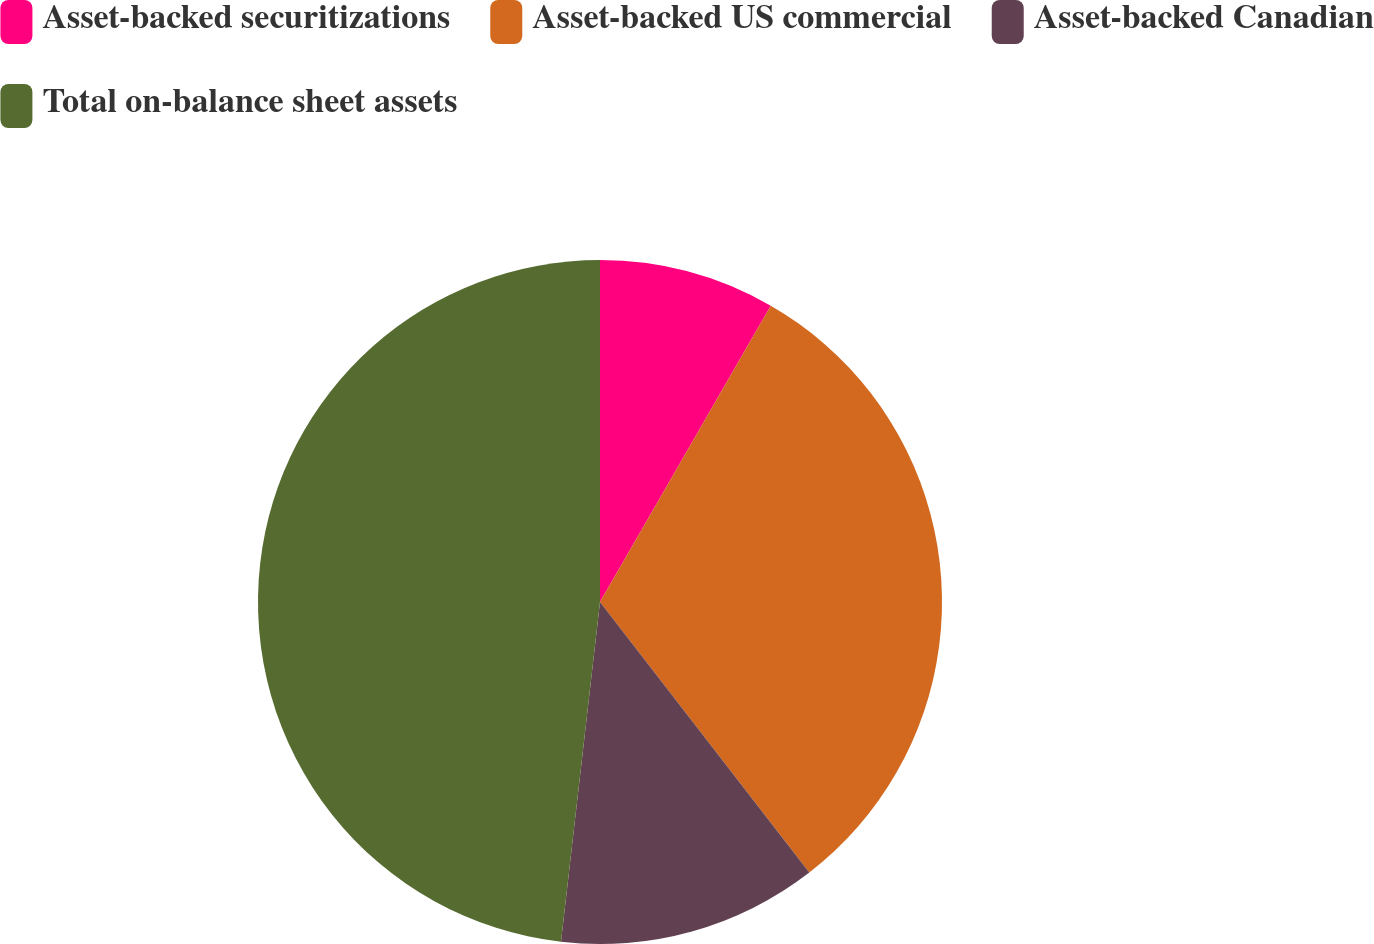<chart> <loc_0><loc_0><loc_500><loc_500><pie_chart><fcel>Asset-backed securitizations<fcel>Asset-backed US commercial<fcel>Asset-backed Canadian<fcel>Total on-balance sheet assets<nl><fcel>8.32%<fcel>31.2%<fcel>12.3%<fcel>48.18%<nl></chart> 